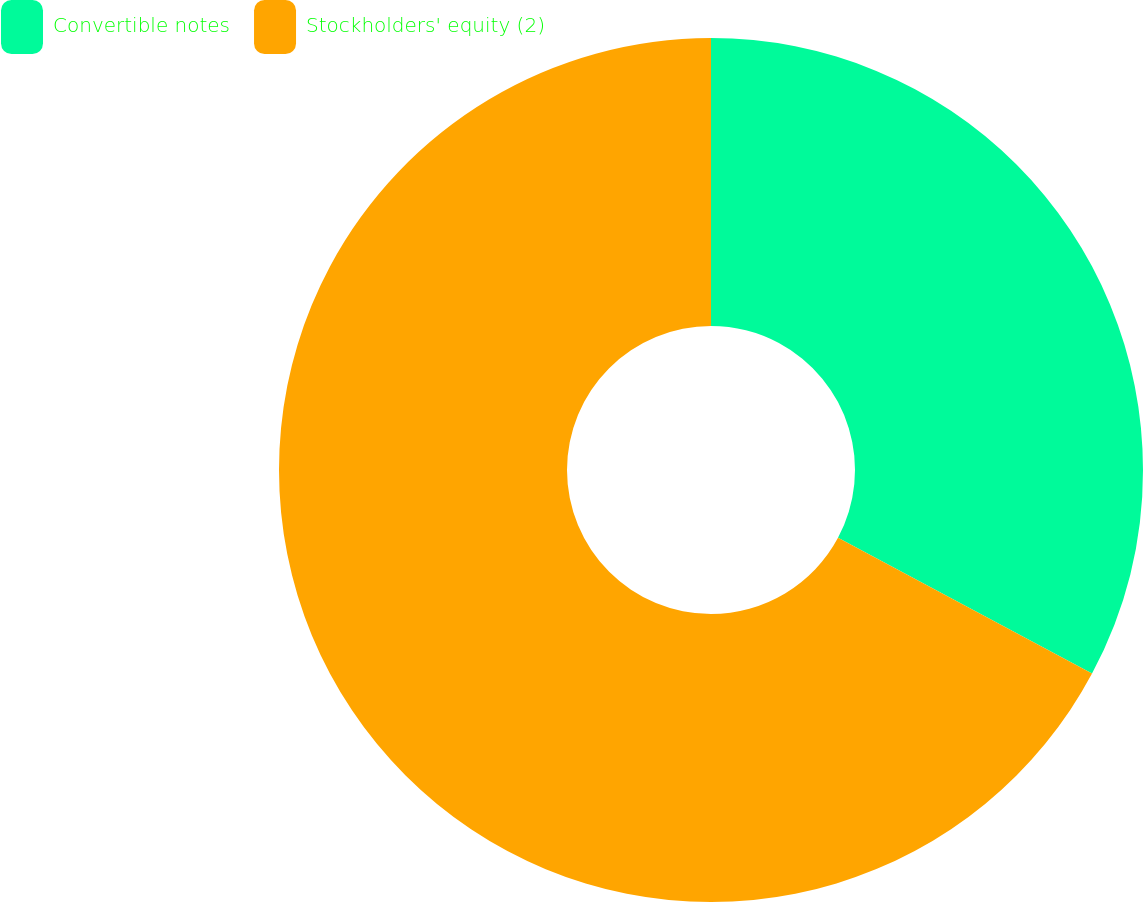Convert chart to OTSL. <chart><loc_0><loc_0><loc_500><loc_500><pie_chart><fcel>Convertible notes<fcel>Stockholders' equity (2)<nl><fcel>32.81%<fcel>67.19%<nl></chart> 